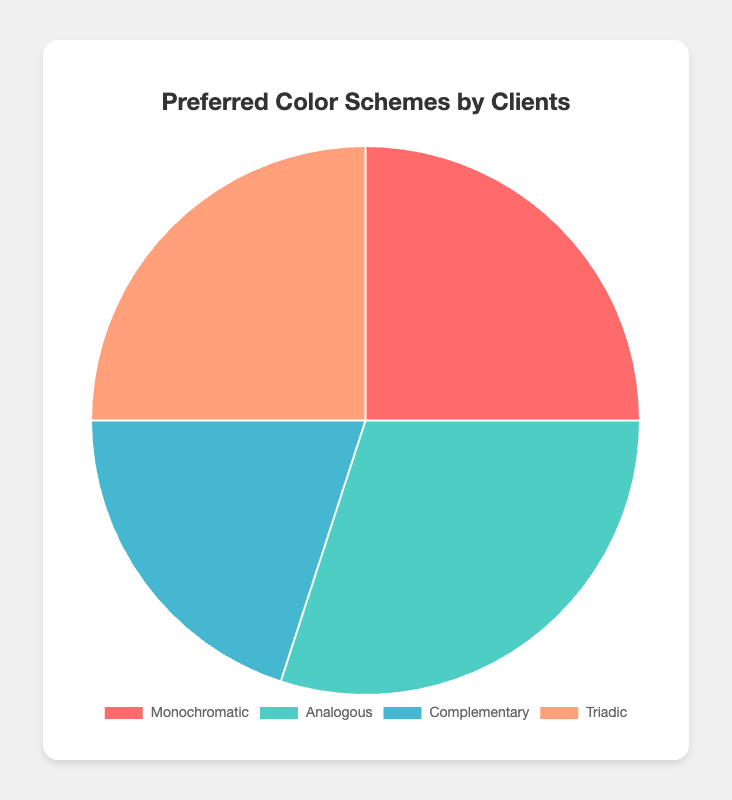Which color scheme has the highest preference among clients? The pie chart shows four segments for the different color schemes. The 'Analogous' segment occupies the largest portion of the pie chart. Therefore, this scheme has the highest preference.
Answer: Analogous What percentage of clients prefer Monochromatic color schemes? The pie chart includes a label indicating the percentage of clients preferring Monochromatic schemes. According to the chart, this percentage is 25%.
Answer: 25% Which two color schemes have an equal preference percentage? By comparing the segments of the pie chart, it is noticeable that Monochromatic and Triadic both occupy the same portion of the pie chart. Both segments are labeled with a 25% preference.
Answer: Monochromatic and Triadic How much more preferred is the Analogous scheme compared to the Complementary scheme? The pie chart shows the Analogous scheme has a preference of 30%, while the Complementary scheme has 20%. The difference is calculated by subtracting 20% from 30%.
Answer: 10% What is the total percentage of clients who prefer either Complementary or Triadic schemes? The Complementary scheme has a 20% preference and the Triadic scheme has a 25% preference. Adding these gives the total percentage: 20% + 25%.
Answer: 45% If you group Monochromatic and Triadic schemes together, what is the combined preference percentage? Both Monochromatic and Triadic schemes have a 25% preference each. Combining them results in: 25% + 25%.
Answer: 50% Which color scheme is represented by the red segment in the pie chart? One of the segments in the pie chart is visually colored red. According to the chart's legend, the red color represents the Monochromatic scheme.
Answer: Monochromatic Between Analogous and Complementary color schemes, which one is preferred less and by how much? The Analogous scheme has a 30% preference, while the Complementary scheme has 20%. The difference indicates how much less the Complementary is preferred: 30% - 20%.
Answer: Complementary, by 10% If a client is equally likely to choose any color scheme, what is the probability that they will pick either Monochromatic or Analogous? The preference percentages for Monochromatic and Analogous are 25% and 30%, respectively. Adding these gives the probability: 25% + 30% = 55%.
Answer: 55% How does the preference for the Triadic scheme compare to the preference for the Complementary scheme? The preference percentage for the Triadic scheme is 25%, and for the Complementary scheme, it is 20%. Since 25% is greater than 20%, Triadic is preferred more.
Answer: Triadic is preferred more (by 5%) 